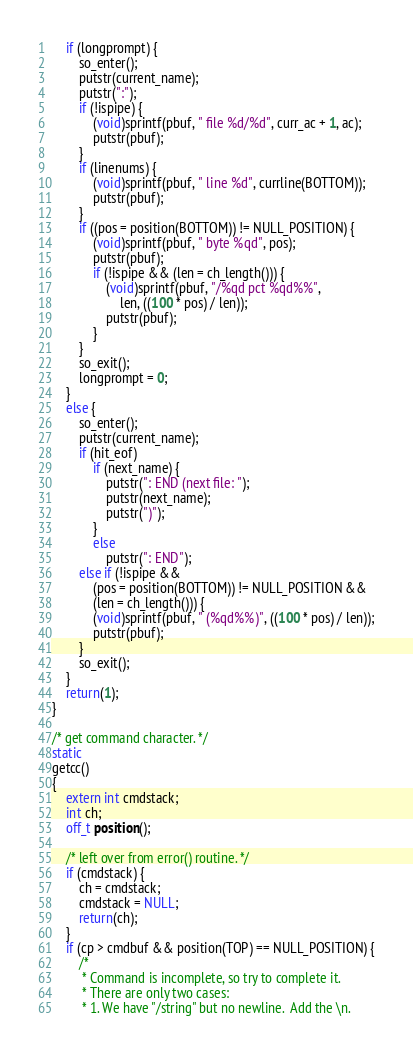<code> <loc_0><loc_0><loc_500><loc_500><_C_>	if (longprompt) {
		so_enter();
		putstr(current_name);
		putstr(":");
		if (!ispipe) {
			(void)sprintf(pbuf, " file %d/%d", curr_ac + 1, ac);
			putstr(pbuf);
		}
		if (linenums) {
			(void)sprintf(pbuf, " line %d", currline(BOTTOM));
			putstr(pbuf);
		}
		if ((pos = position(BOTTOM)) != NULL_POSITION) {
			(void)sprintf(pbuf, " byte %qd", pos);
			putstr(pbuf);
			if (!ispipe && (len = ch_length())) {
				(void)sprintf(pbuf, "/%qd pct %qd%%",
				    len, ((100 * pos) / len));
				putstr(pbuf);
			}
		}
		so_exit();
		longprompt = 0;
	}
	else {
		so_enter();
		putstr(current_name);
		if (hit_eof)
			if (next_name) {
				putstr(": END (next file: ");
				putstr(next_name);
				putstr(")");
			}
			else
				putstr(": END");
		else if (!ispipe &&
		    (pos = position(BOTTOM)) != NULL_POSITION &&
		    (len = ch_length())) {
			(void)sprintf(pbuf, " (%qd%%)", ((100 * pos) / len));
			putstr(pbuf);
		}
		so_exit();
	}
	return(1);
}

/* get command character. */
static
getcc()
{
	extern int cmdstack;
	int ch;
	off_t position();

	/* left over from error() routine. */
	if (cmdstack) {
		ch = cmdstack;
		cmdstack = NULL;
		return(ch);
	}
	if (cp > cmdbuf && position(TOP) == NULL_POSITION) {
		/*
		 * Command is incomplete, so try to complete it.
		 * There are only two cases:
		 * 1. We have "/string" but no newline.  Add the \n.</code> 